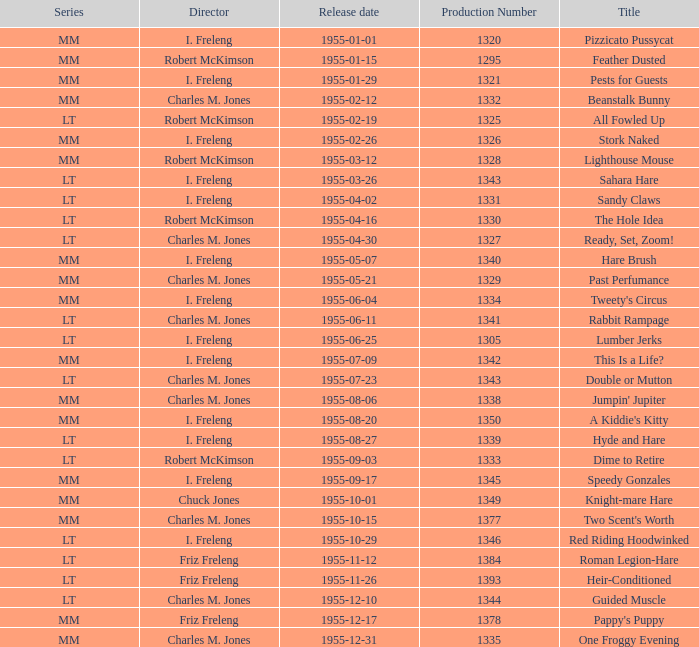What is the highest production number released on 1955-04-02 with i. freleng as the director? 1331.0. 